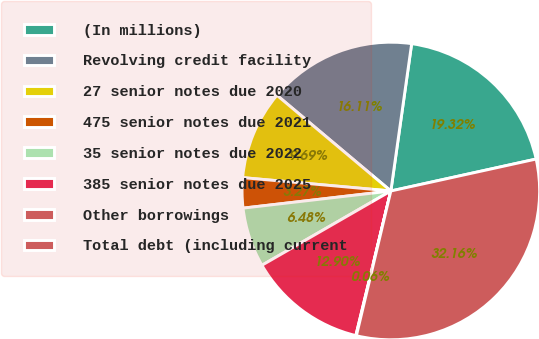Convert chart to OTSL. <chart><loc_0><loc_0><loc_500><loc_500><pie_chart><fcel>(In millions)<fcel>Revolving credit facility<fcel>27 senior notes due 2020<fcel>475 senior notes due 2021<fcel>35 senior notes due 2022<fcel>385 senior notes due 2025<fcel>Other borrowings<fcel>Total debt (including current<nl><fcel>19.32%<fcel>16.11%<fcel>9.69%<fcel>3.27%<fcel>6.48%<fcel>12.9%<fcel>0.06%<fcel>32.16%<nl></chart> 